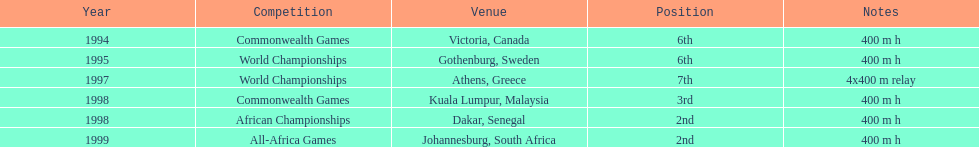What is the count of titles ken harden has achieved? 6. 